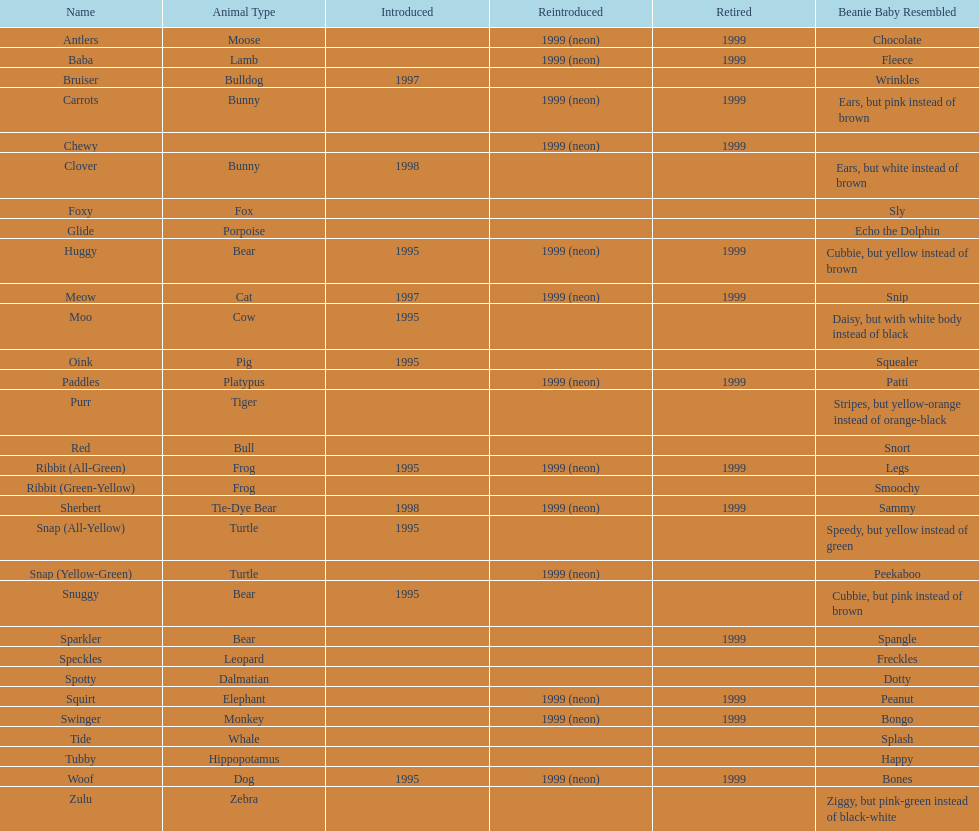What is the total number of pillow pals that were reintroduced as a neon variety? 13. 